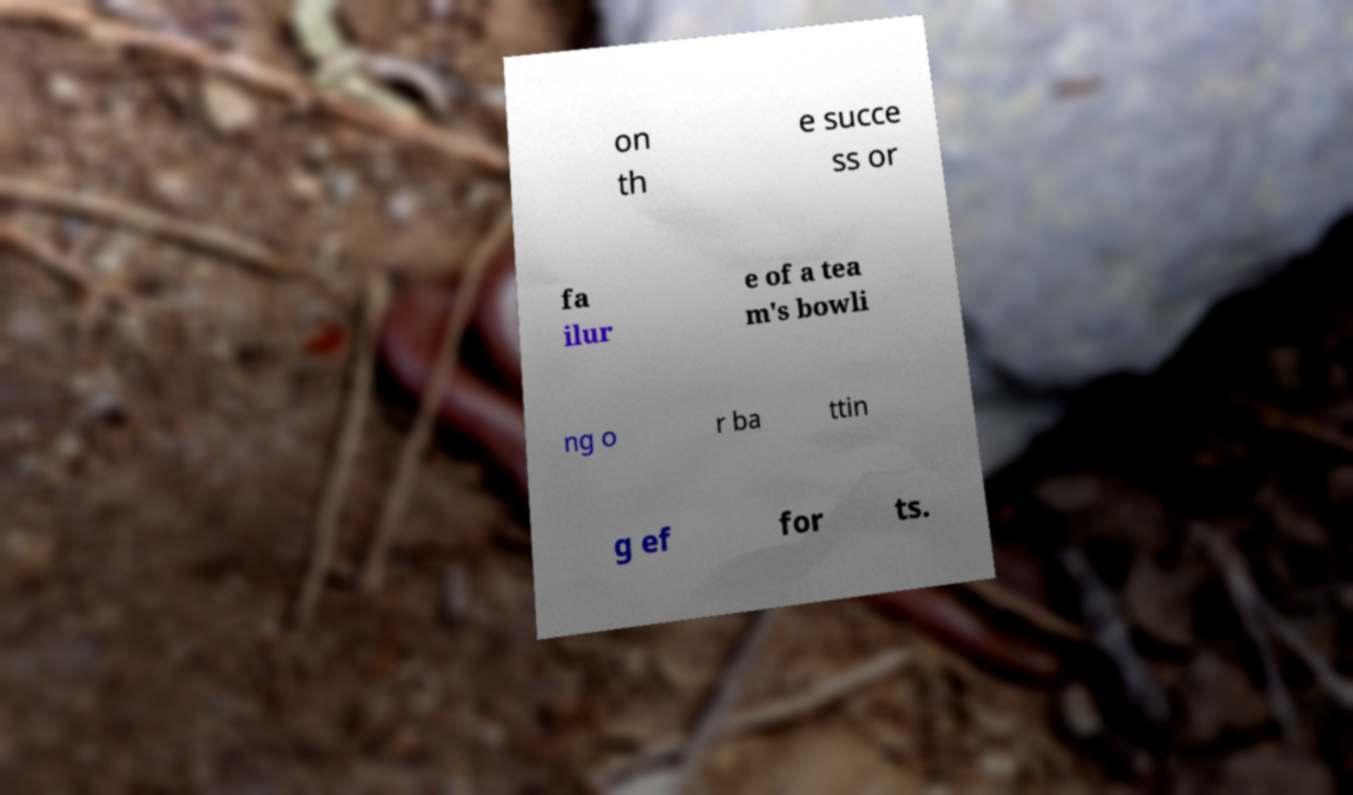There's text embedded in this image that I need extracted. Can you transcribe it verbatim? on th e succe ss or fa ilur e of a tea m's bowli ng o r ba ttin g ef for ts. 